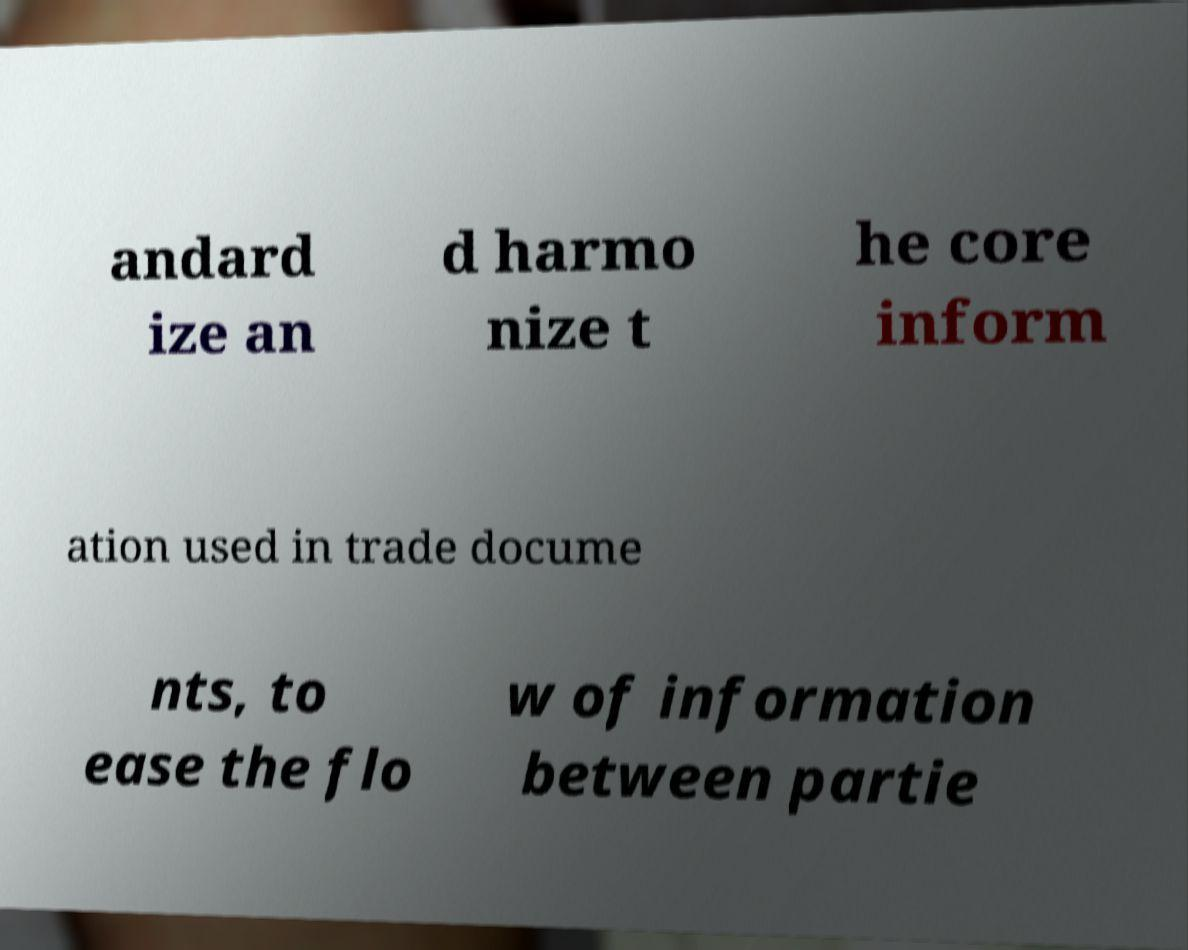There's text embedded in this image that I need extracted. Can you transcribe it verbatim? andard ize an d harmo nize t he core inform ation used in trade docume nts, to ease the flo w of information between partie 